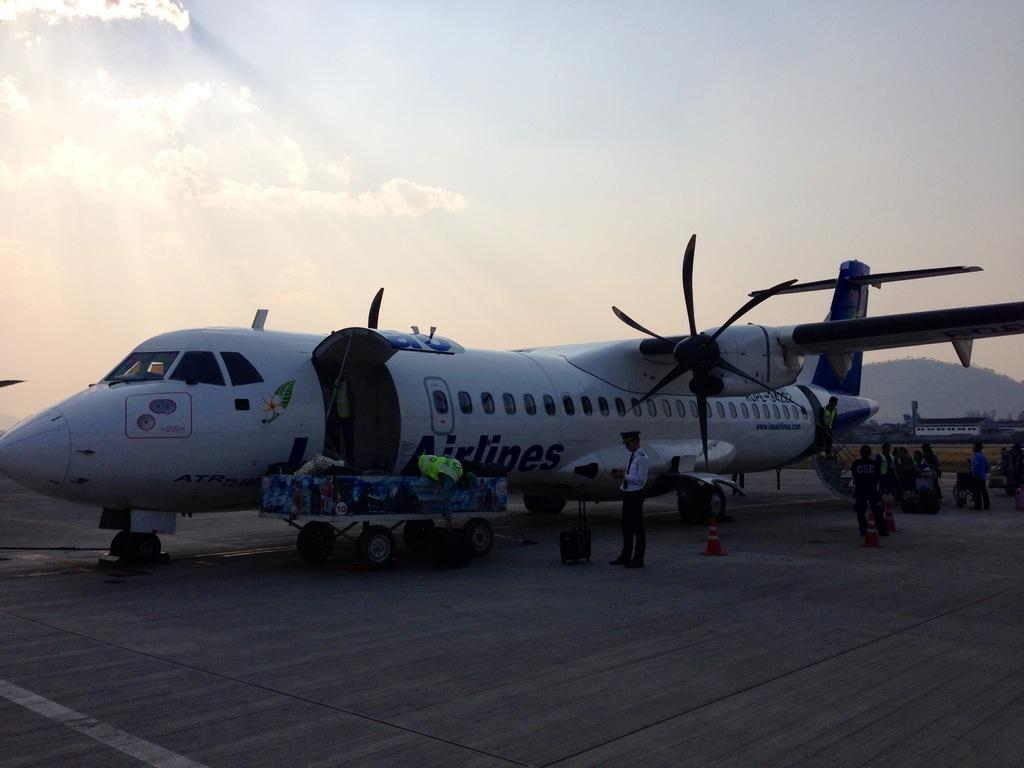What is the main subject of the image? The main subject of the image is an airplane on the ground. What objects are present in the image to control traffic or guide people? There are traffic cones in the image. Can you describe the people in the image? There are people in the image, but their specific actions or roles are not clear. What type of structures can be seen in the image? There are buildings in the image. What type of vegetation is present in the image? There are trees in the image. What is the person carrying in the image? There is a trolley bag in the image. What is visible in the sky in the image? The sky is visible in the image, and clouds are present. What type of watch is the person wearing in the image? There is no watch visible on any person in the image. What are the people in the image learning about? There is no indication of any learning activity taking place in the image. 